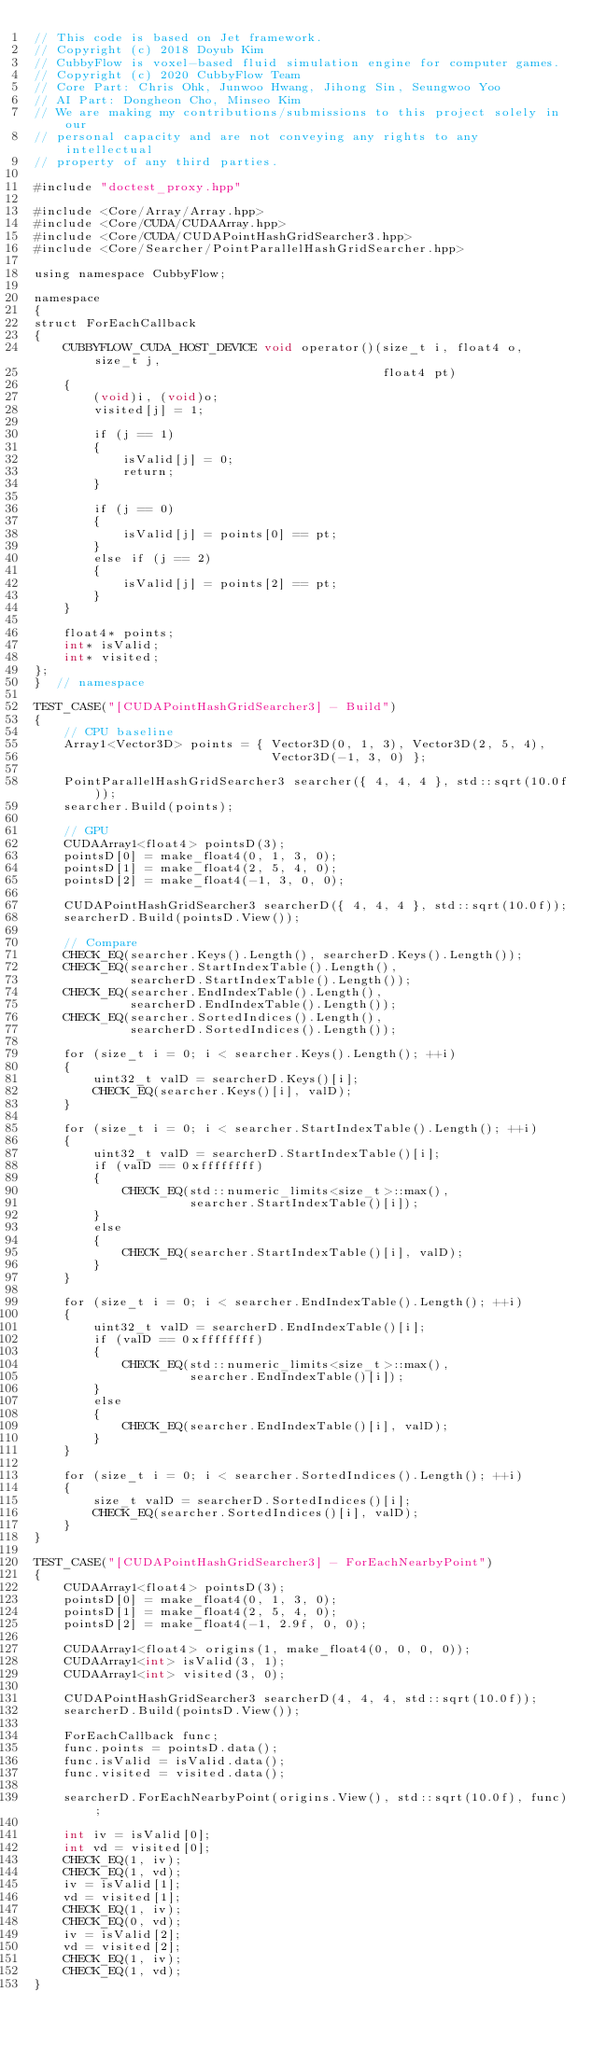Convert code to text. <code><loc_0><loc_0><loc_500><loc_500><_Cuda_>// This code is based on Jet framework.
// Copyright (c) 2018 Doyub Kim
// CubbyFlow is voxel-based fluid simulation engine for computer games.
// Copyright (c) 2020 CubbyFlow Team
// Core Part: Chris Ohk, Junwoo Hwang, Jihong Sin, Seungwoo Yoo
// AI Part: Dongheon Cho, Minseo Kim
// We are making my contributions/submissions to this project solely in our
// personal capacity and are not conveying any rights to any intellectual
// property of any third parties.

#include "doctest_proxy.hpp"

#include <Core/Array/Array.hpp>
#include <Core/CUDA/CUDAArray.hpp>
#include <Core/CUDA/CUDAPointHashGridSearcher3.hpp>
#include <Core/Searcher/PointParallelHashGridSearcher.hpp>

using namespace CubbyFlow;

namespace
{
struct ForEachCallback
{
    CUBBYFLOW_CUDA_HOST_DEVICE void operator()(size_t i, float4 o, size_t j,
                                               float4 pt)
    {
        (void)i, (void)o;
        visited[j] = 1;

        if (j == 1)
        {
            isValid[j] = 0;
            return;
        }

        if (j == 0)
        {
            isValid[j] = points[0] == pt;
        }
        else if (j == 2)
        {
            isValid[j] = points[2] == pt;
        }
    }

    float4* points;
    int* isValid;
    int* visited;
};
}  // namespace

TEST_CASE("[CUDAPointHashGridSearcher3] - Build")
{
    // CPU baseline
    Array1<Vector3D> points = { Vector3D(0, 1, 3), Vector3D(2, 5, 4),
                                Vector3D(-1, 3, 0) };

    PointParallelHashGridSearcher3 searcher({ 4, 4, 4 }, std::sqrt(10.0f));
    searcher.Build(points);

    // GPU
    CUDAArray1<float4> pointsD(3);
    pointsD[0] = make_float4(0, 1, 3, 0);
    pointsD[1] = make_float4(2, 5, 4, 0);
    pointsD[2] = make_float4(-1, 3, 0, 0);

    CUDAPointHashGridSearcher3 searcherD({ 4, 4, 4 }, std::sqrt(10.0f));
    searcherD.Build(pointsD.View());

    // Compare
    CHECK_EQ(searcher.Keys().Length(), searcherD.Keys().Length());
    CHECK_EQ(searcher.StartIndexTable().Length(),
             searcherD.StartIndexTable().Length());
    CHECK_EQ(searcher.EndIndexTable().Length(),
             searcherD.EndIndexTable().Length());
    CHECK_EQ(searcher.SortedIndices().Length(),
             searcherD.SortedIndices().Length());

    for (size_t i = 0; i < searcher.Keys().Length(); ++i)
    {
        uint32_t valD = searcherD.Keys()[i];
        CHECK_EQ(searcher.Keys()[i], valD);
    }

    for (size_t i = 0; i < searcher.StartIndexTable().Length(); ++i)
    {
        uint32_t valD = searcherD.StartIndexTable()[i];
        if (valD == 0xffffffff)
        {
            CHECK_EQ(std::numeric_limits<size_t>::max(),
                     searcher.StartIndexTable()[i]);
        }
        else
        {
            CHECK_EQ(searcher.StartIndexTable()[i], valD);
        }
    }

    for (size_t i = 0; i < searcher.EndIndexTable().Length(); ++i)
    {
        uint32_t valD = searcherD.EndIndexTable()[i];
        if (valD == 0xffffffff)
        {
            CHECK_EQ(std::numeric_limits<size_t>::max(),
                     searcher.EndIndexTable()[i]);
        }
        else
        {
            CHECK_EQ(searcher.EndIndexTable()[i], valD);
        }
    }

    for (size_t i = 0; i < searcher.SortedIndices().Length(); ++i)
    {
        size_t valD = searcherD.SortedIndices()[i];
        CHECK_EQ(searcher.SortedIndices()[i], valD);
    }
}

TEST_CASE("[CUDAPointHashGridSearcher3] - ForEachNearbyPoint")
{
    CUDAArray1<float4> pointsD(3);
    pointsD[0] = make_float4(0, 1, 3, 0);
    pointsD[1] = make_float4(2, 5, 4, 0);
    pointsD[2] = make_float4(-1, 2.9f, 0, 0);

    CUDAArray1<float4> origins(1, make_float4(0, 0, 0, 0));
    CUDAArray1<int> isValid(3, 1);
    CUDAArray1<int> visited(3, 0);

    CUDAPointHashGridSearcher3 searcherD(4, 4, 4, std::sqrt(10.0f));
    searcherD.Build(pointsD.View());

    ForEachCallback func;
    func.points = pointsD.data();
    func.isValid = isValid.data();
    func.visited = visited.data();

    searcherD.ForEachNearbyPoint(origins.View(), std::sqrt(10.0f), func);

    int iv = isValid[0];
    int vd = visited[0];
    CHECK_EQ(1, iv);
    CHECK_EQ(1, vd);
    iv = isValid[1];
    vd = visited[1];
    CHECK_EQ(1, iv);
    CHECK_EQ(0, vd);
    iv = isValid[2];
    vd = visited[2];
    CHECK_EQ(1, iv);
    CHECK_EQ(1, vd);
}</code> 